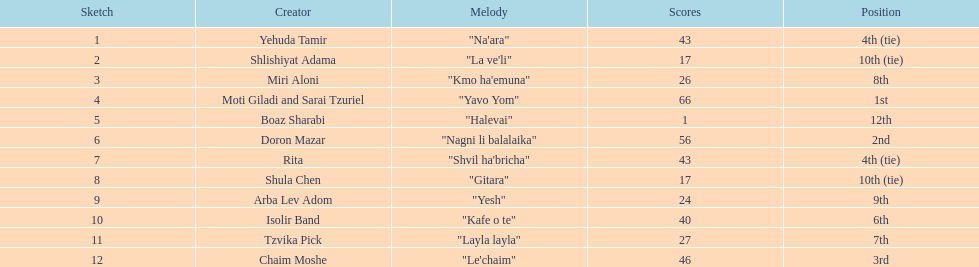Which artist had almost no points? Boaz Sharabi. 